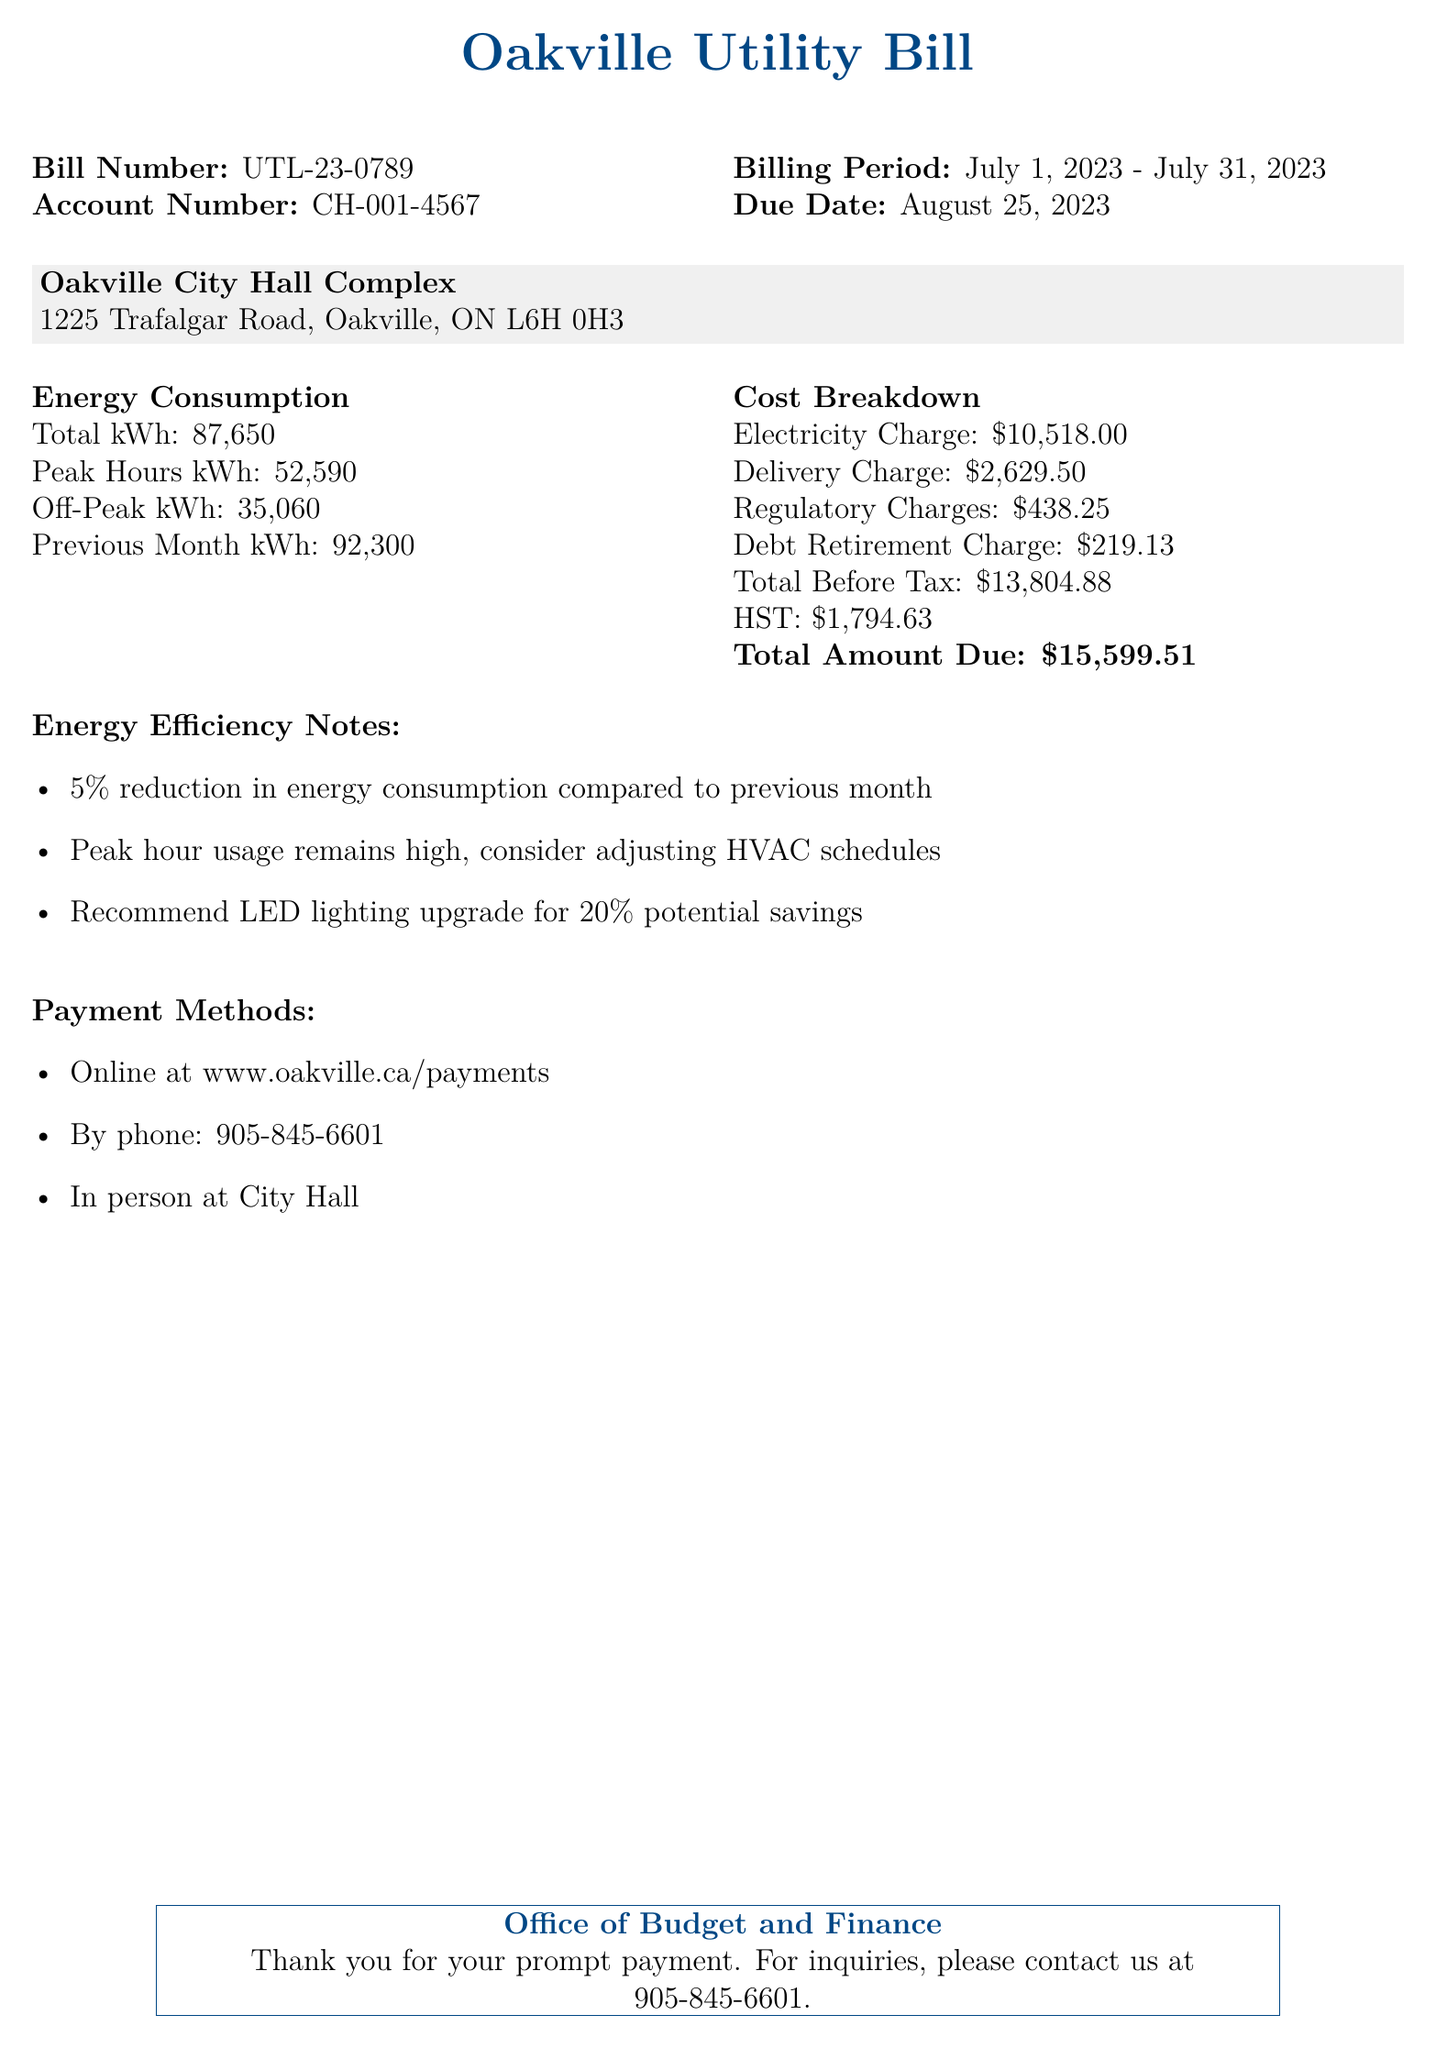What is the total energy consumption for the billing period? The total energy consumption is listed as 87,650 kWh in the document.
Answer: 87,650 kWh What is the due date for the bill? The due date for the bill is explicitly mentioned.
Answer: August 25, 2023 How much was charged for the electricity? The electricity charge is detailed in the cost breakdown section.
Answer: $10,518.00 What percentage reduction in energy consumption is noted compared to the previous month? A reduction percentage is provided in the energy efficiency notes section.
Answer: 5% What is the account number associated with this utility bill? The account number is stated at the top of the document.
Answer: CH-001-4567 What is the total amount due after tax? The total amount due is provided in the cost breakdown.
Answer: $15,599.51 How many kilowatt hours were used during peak hours? Peak hours kWh usage is included in the energy consumption section.
Answer: 52,590 kWh What recommendation is provided for potential energy savings? The document includes a recommendation for energy savings in the energy efficiency notes.
Answer: LED lighting upgrade for 20% potential savings What is the total regulatory charge listed? The regulatory charges are outlined in the cost breakdown section of the document.
Answer: $438.25 